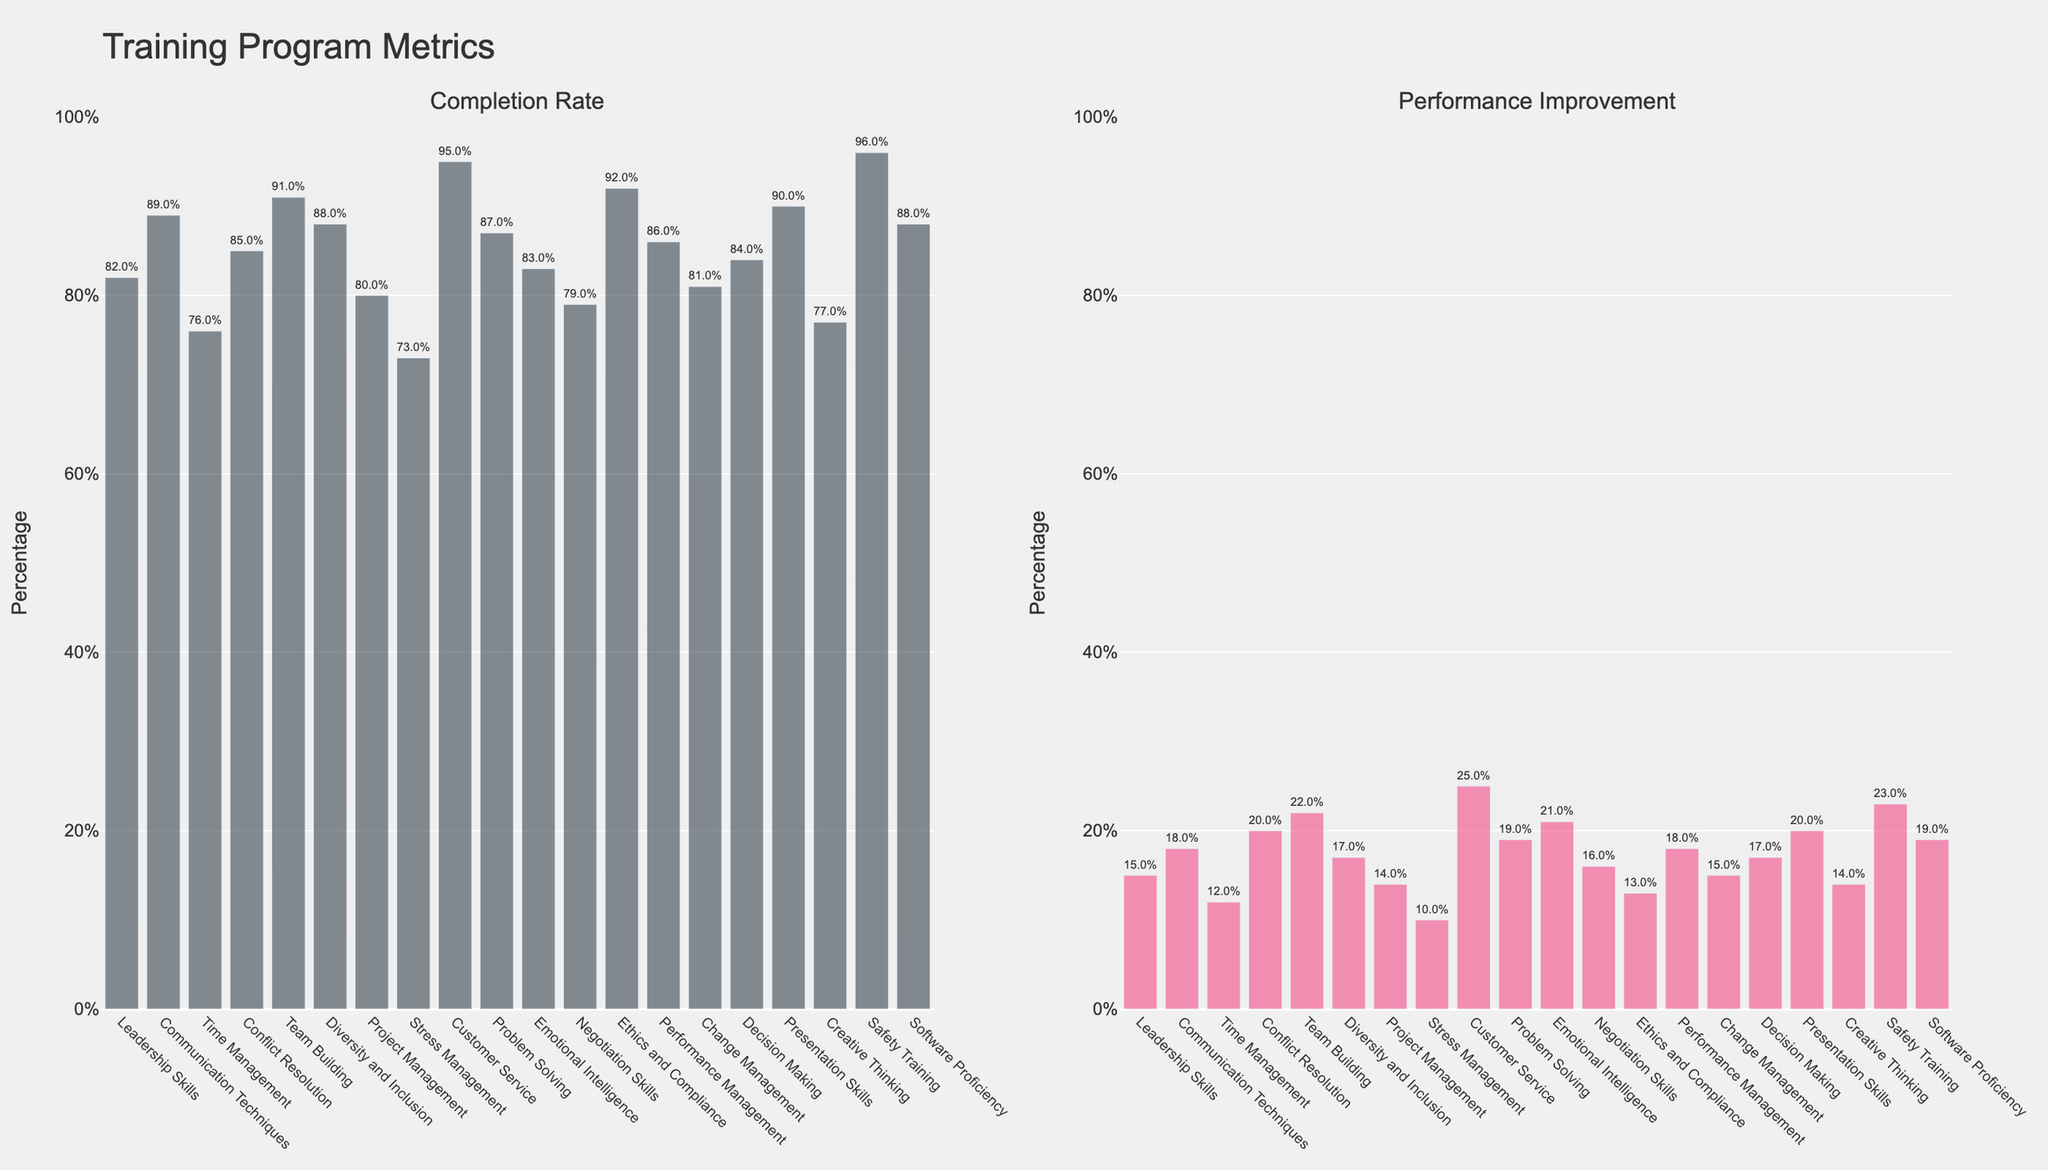What's the training program with the highest performance improvement? The training program with the highest performance improvement is identified by the tallest red or pink bar in the 'Performance Improvement' subplot. Customer Service has the highest bar, representing performance improvement.
Answer: Customer Service What is the difference between the completion rates of Safety Training and Stress Management? Safety Training has a completion rate of 96%, and Stress Management has a completion rate of 73%. The difference is calculated by subtracting 73 from 96.
Answer: 23% Which training program has a higher completion rate, Leadership Skills or Project Management? Compare the heights of the bars in the 'Completion Rate' subplot for Leadership Skills (82%) and Project Management (80%). Leadership Skills has a higher completion rate.
Answer: Leadership Skills What's the average performance improvement for the programs with a completion rate above 90%? Only Customer Service, Ethics and Compliance, Team Building, and Presentation Skills have completion rates above 90%. Their performance improvements are 25%, 13%, 22%, and 20%. The average is calculated as (25 + 13 + 22 + 20) / 4.
Answer: 20% How does the performance improvement of Conflict Resolution compare to that of Time Management? In the 'Performance Improvement' subplot, Conflict Resolution has a performance improvement of 20%, while Time Management has 12%. A comparison shows that Conflict Resolution has a higher performance improvement.
Answer: Conflict Resolution What is the relation between completion rates and performance improvements for Stress Management and Software Proficiency? Stress Management has a completion rate of 73% and a performance improvement of 10%. Software Proficiency has a completion rate of 88% and a performance improvement of 19%. Software Proficiency has higher values for both metrics.
Answer: Software Proficiency shows higher completion rates and performance improvements Which training program has the closest completion rate to Problem Solving? Problem Solving has a completion rate of 87%. The closest completion rate in the 'Completion Rate' subplot is Communication Techniques with an 89% completion rate.
Answer: Communication Techniques What percentage of improvement does the training program with the lowest completion rate yield? Stress Management has the lowest completion rate of 73%. Its performance improvement is indicated by the height of the bar in the 'Performance Improvement' subplot, which is 10%.
Answer: 10% What is the combined performance improvement percentage for the training programs focusing on managerial skills (Leadership Skills, Performance Management, and Change Management)? Performance improvements for Leadership Skills, Performance Management, and Change Management are 15%, 18%, and 15%, respectively. The combined improvement is the sum of these values: 15 + 18 + 15.
Answer: 48% How many training programs have a performance improvement of 20% or higher? In the 'Performance Improvement' subplot, bars representing Customer Service (25%), Team Building (22%), Emotional Intelligence (21%), Conflict Resolution (20%), and Presentation Skills (20%) meet the criteria. Count these bars.
Answer: 5 programs 